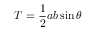<formula> <loc_0><loc_0><loc_500><loc_500>T = { \frac { 1 } { 2 } } a b \sin \theta</formula> 